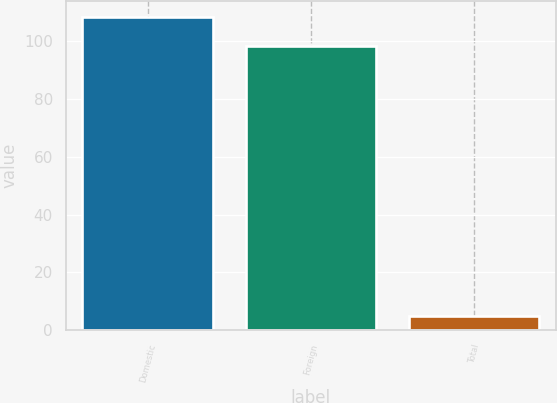<chart> <loc_0><loc_0><loc_500><loc_500><bar_chart><fcel>Domestic<fcel>Foreign<fcel>Total<nl><fcel>108.35<fcel>98.5<fcel>5<nl></chart> 